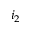<formula> <loc_0><loc_0><loc_500><loc_500>i _ { 2 }</formula> 